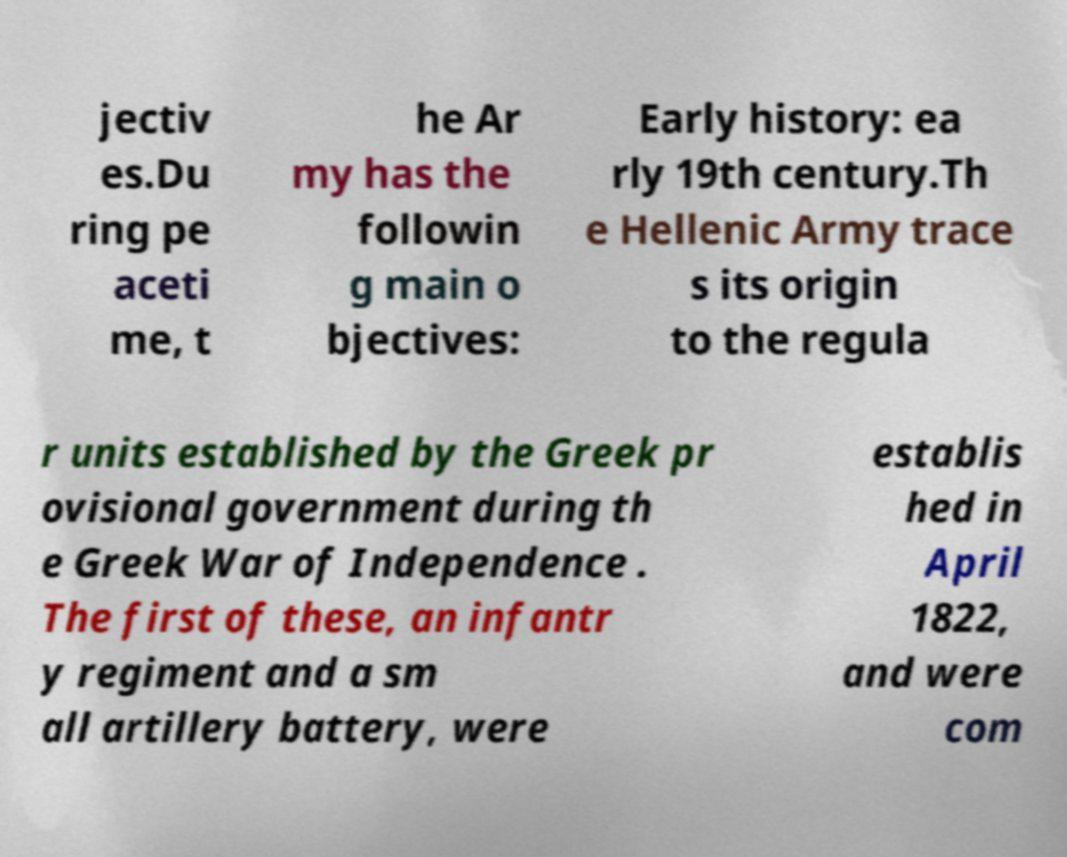Can you read and provide the text displayed in the image?This photo seems to have some interesting text. Can you extract and type it out for me? jectiv es.Du ring pe aceti me, t he Ar my has the followin g main o bjectives: Early history: ea rly 19th century.Th e Hellenic Army trace s its origin to the regula r units established by the Greek pr ovisional government during th e Greek War of Independence . The first of these, an infantr y regiment and a sm all artillery battery, were establis hed in April 1822, and were com 